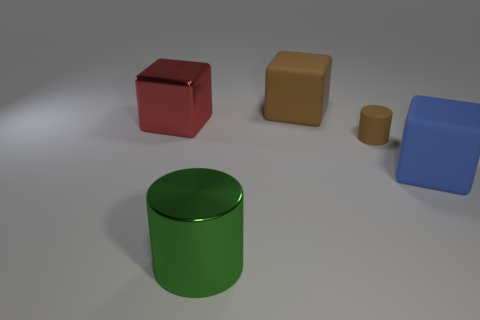There is a brown rubber object that is in front of the big metal thing to the left of the big cylinder; are there any big red metallic blocks behind it?
Give a very brief answer. Yes. Are the large cylinder and the big red thing made of the same material?
Provide a short and direct response. Yes. What material is the cylinder left of the big rubber cube that is left of the big blue matte cube made of?
Offer a very short reply. Metal. How big is the shiny thing that is behind the green shiny cylinder?
Your answer should be very brief. Large. There is a cube that is behind the large blue matte object and right of the red metal block; what color is it?
Provide a short and direct response. Brown. Do the matte cube in front of the red metal object and the red shiny cube have the same size?
Provide a short and direct response. Yes. Are there any big red blocks that are to the right of the big rubber block in front of the big brown rubber block?
Your response must be concise. No. What is the material of the big green cylinder?
Provide a short and direct response. Metal. Are there any red blocks behind the metal block?
Make the answer very short. No. What is the size of the red metallic thing that is the same shape as the blue matte object?
Offer a terse response. Large. 